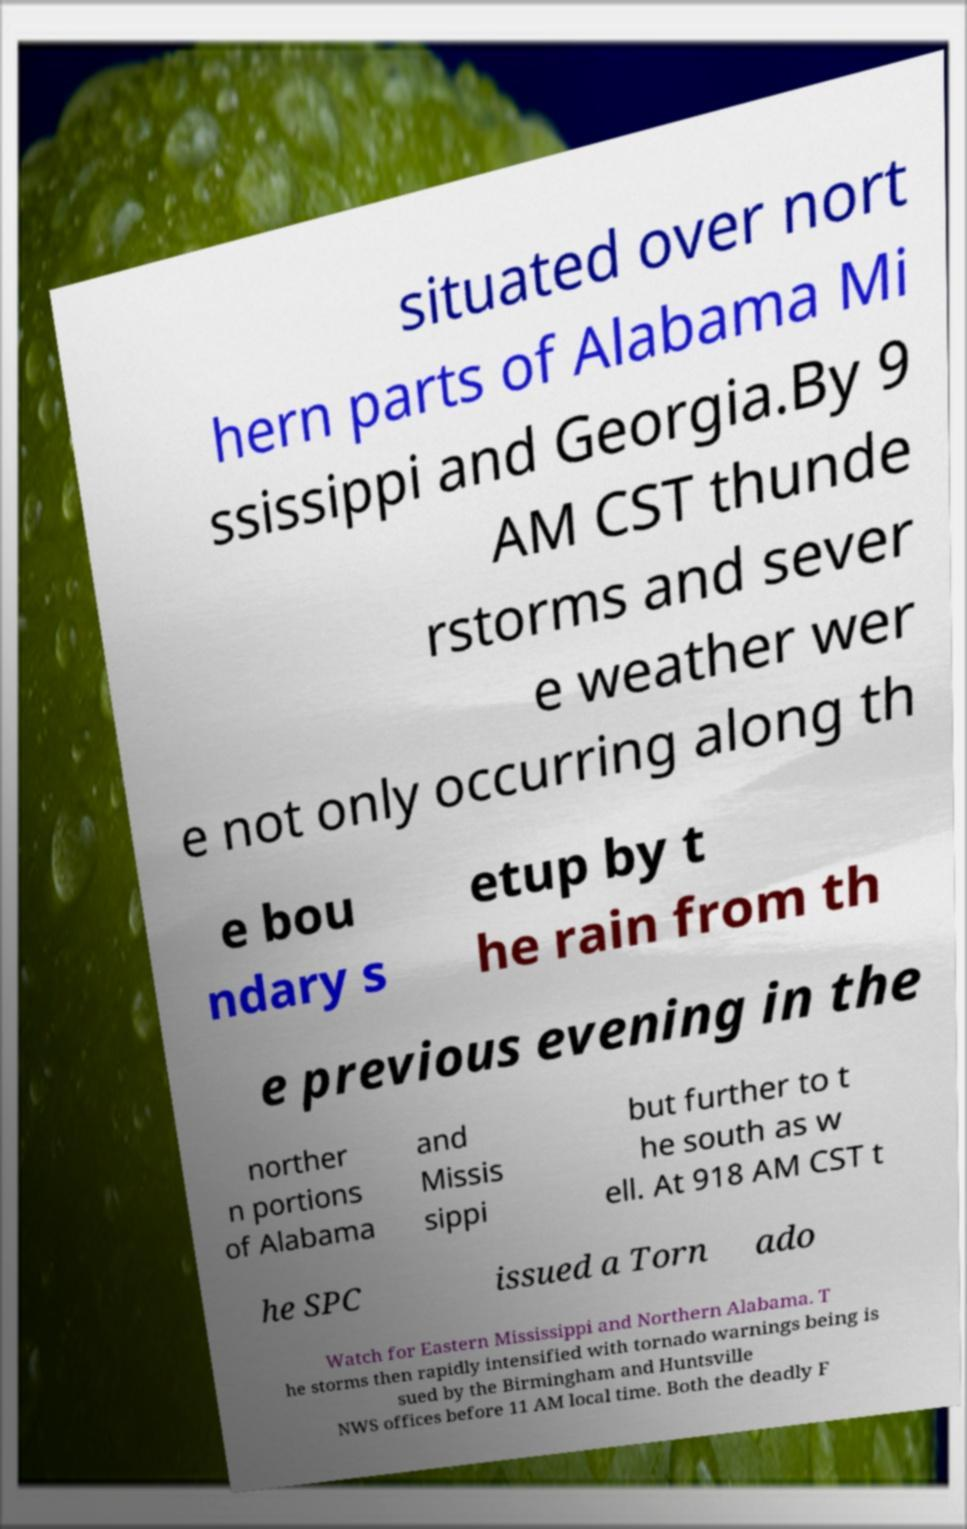Could you extract and type out the text from this image? situated over nort hern parts of Alabama Mi ssissippi and Georgia.By 9 AM CST thunde rstorms and sever e weather wer e not only occurring along th e bou ndary s etup by t he rain from th e previous evening in the norther n portions of Alabama and Missis sippi but further to t he south as w ell. At 918 AM CST t he SPC issued a Torn ado Watch for Eastern Mississippi and Northern Alabama. T he storms then rapidly intensified with tornado warnings being is sued by the Birmingham and Huntsville NWS offices before 11 AM local time. Both the deadly F 